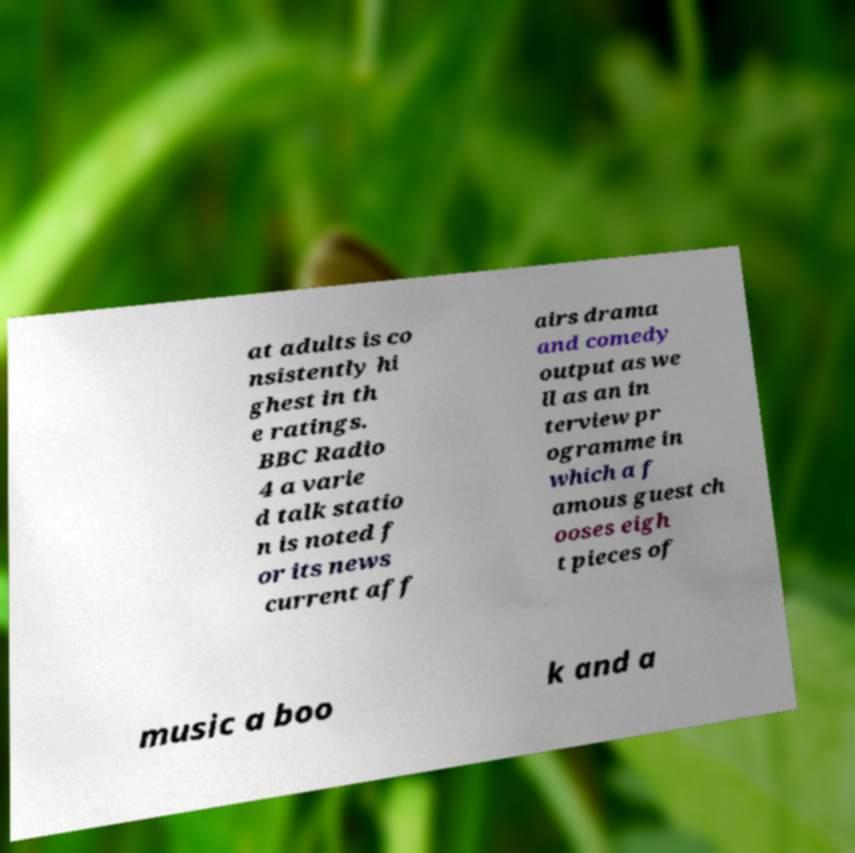Can you read and provide the text displayed in the image?This photo seems to have some interesting text. Can you extract and type it out for me? at adults is co nsistently hi ghest in th e ratings. BBC Radio 4 a varie d talk statio n is noted f or its news current aff airs drama and comedy output as we ll as an in terview pr ogramme in which a f amous guest ch ooses eigh t pieces of music a boo k and a 